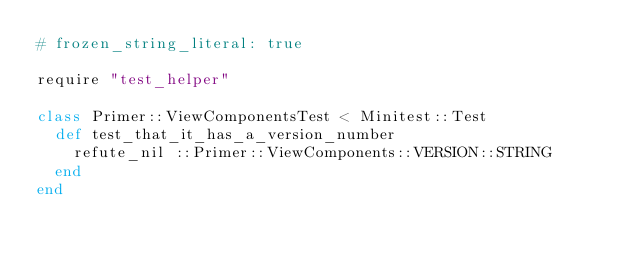<code> <loc_0><loc_0><loc_500><loc_500><_Ruby_># frozen_string_literal: true

require "test_helper"

class Primer::ViewComponentsTest < Minitest::Test
  def test_that_it_has_a_version_number
    refute_nil ::Primer::ViewComponents::VERSION::STRING
  end
end
</code> 